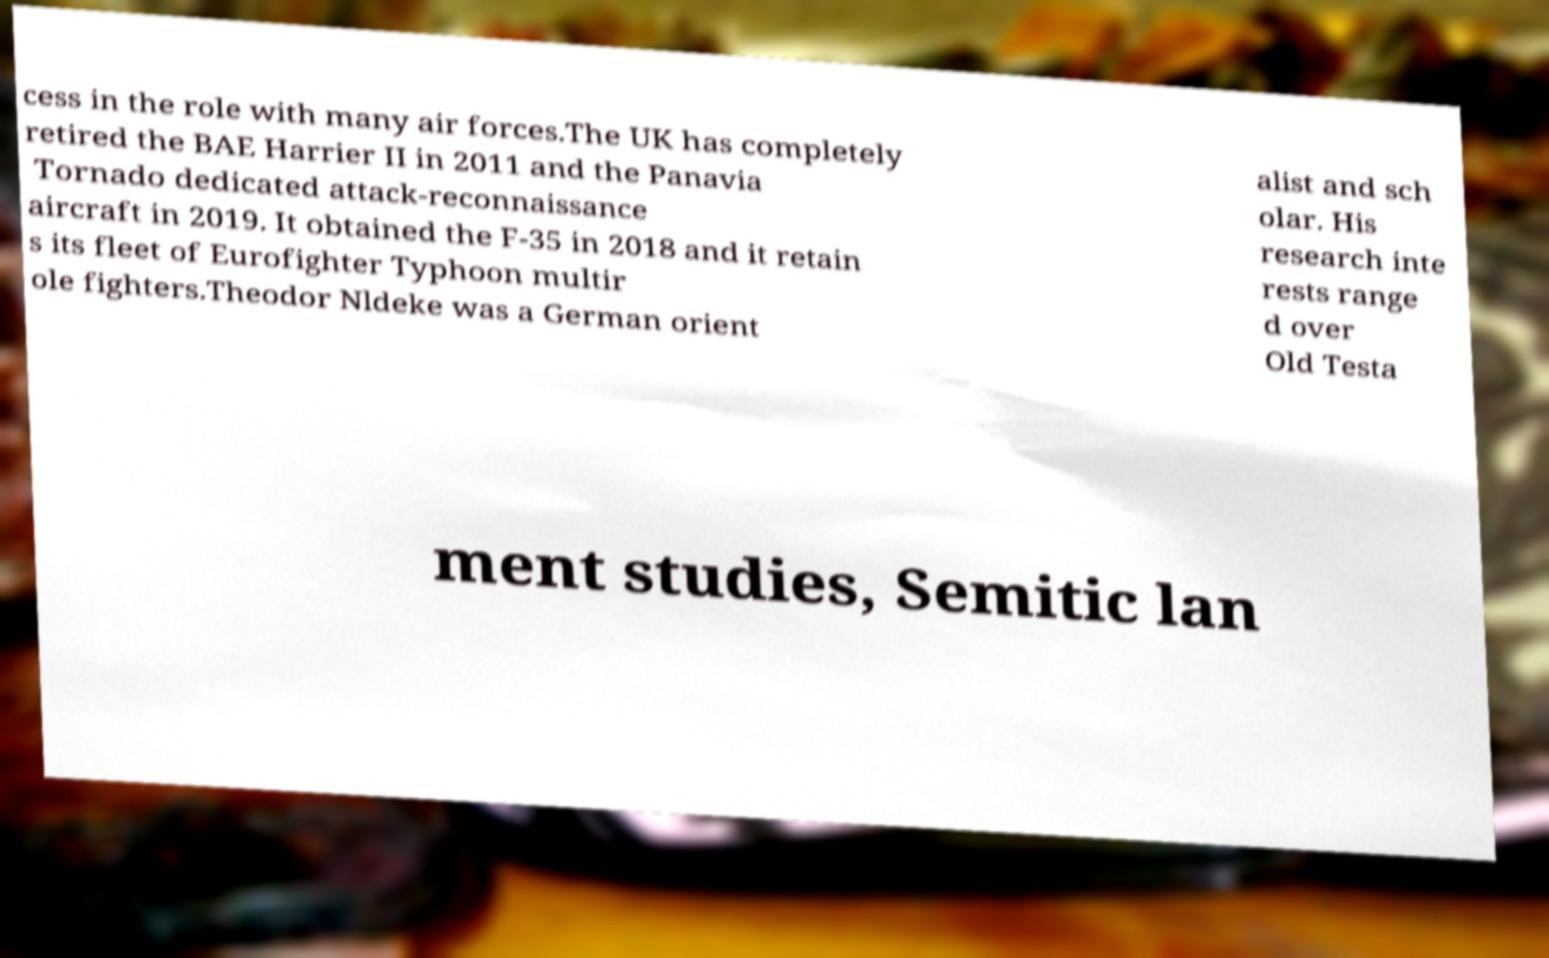Can you accurately transcribe the text from the provided image for me? cess in the role with many air forces.The UK has completely retired the BAE Harrier II in 2011 and the Panavia Tornado dedicated attack-reconnaissance aircraft in 2019. It obtained the F-35 in 2018 and it retain s its fleet of Eurofighter Typhoon multir ole fighters.Theodor Nldeke was a German orient alist and sch olar. His research inte rests range d over Old Testa ment studies, Semitic lan 